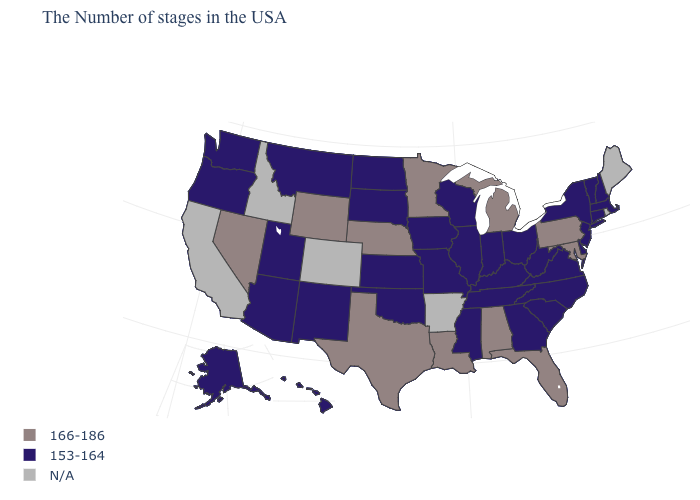What is the value of Maryland?
Concise answer only. 166-186. How many symbols are there in the legend?
Concise answer only. 3. What is the value of Georgia?
Write a very short answer. 153-164. What is the value of New Hampshire?
Keep it brief. 153-164. What is the value of New York?
Short answer required. 153-164. Name the states that have a value in the range 153-164?
Keep it brief. Massachusetts, New Hampshire, Vermont, Connecticut, New York, New Jersey, Delaware, Virginia, North Carolina, South Carolina, West Virginia, Ohio, Georgia, Kentucky, Indiana, Tennessee, Wisconsin, Illinois, Mississippi, Missouri, Iowa, Kansas, Oklahoma, South Dakota, North Dakota, New Mexico, Utah, Montana, Arizona, Washington, Oregon, Alaska, Hawaii. Among the states that border New Mexico , does Texas have the highest value?
Give a very brief answer. Yes. What is the highest value in the West ?
Write a very short answer. 166-186. Which states have the lowest value in the Northeast?
Quick response, please. Massachusetts, New Hampshire, Vermont, Connecticut, New York, New Jersey. What is the value of Alabama?
Quick response, please. 166-186. Does Ohio have the highest value in the USA?
Be succinct. No. Does Florida have the highest value in the South?
Answer briefly. Yes. Name the states that have a value in the range N/A?
Keep it brief. Maine, Rhode Island, Arkansas, Colorado, Idaho, California. Does Virginia have the lowest value in the South?
Short answer required. Yes. 